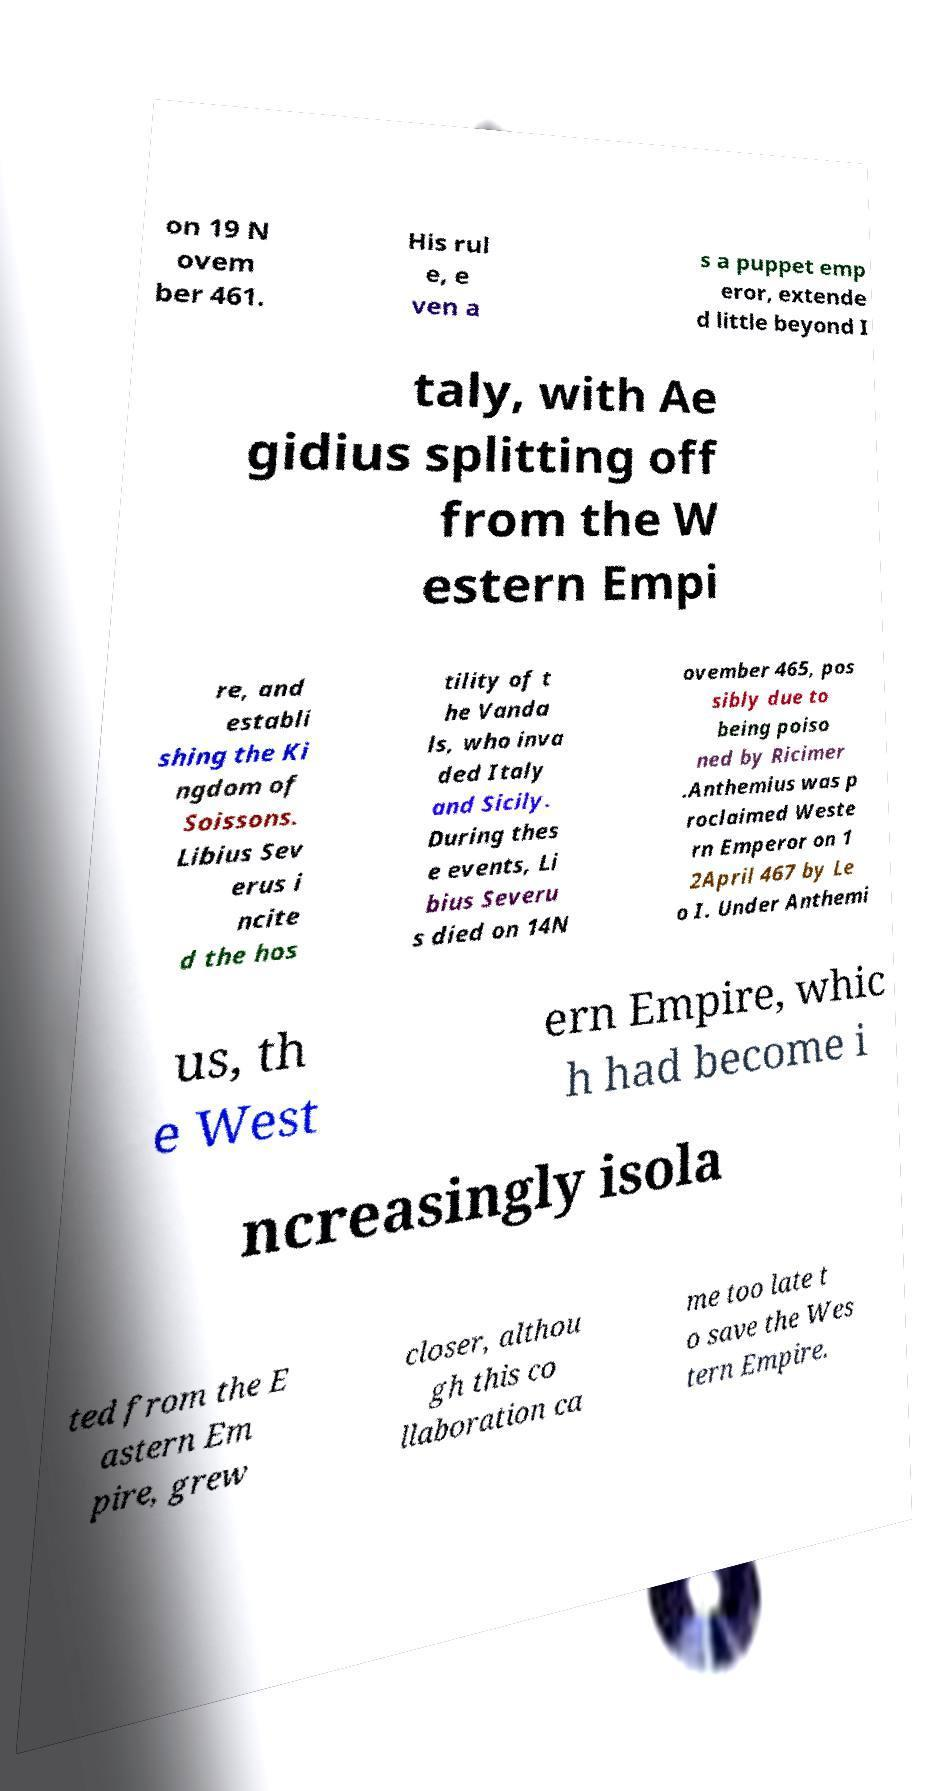Can you accurately transcribe the text from the provided image for me? on 19 N ovem ber 461. His rul e, e ven a s a puppet emp eror, extende d little beyond I taly, with Ae gidius splitting off from the W estern Empi re, and establi shing the Ki ngdom of Soissons. Libius Sev erus i ncite d the hos tility of t he Vanda ls, who inva ded Italy and Sicily. During thes e events, Li bius Severu s died on 14N ovember 465, pos sibly due to being poiso ned by Ricimer .Anthemius was p roclaimed Weste rn Emperor on 1 2April 467 by Le o I. Under Anthemi us, th e West ern Empire, whic h had become i ncreasingly isola ted from the E astern Em pire, grew closer, althou gh this co llaboration ca me too late t o save the Wes tern Empire. 